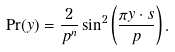<formula> <loc_0><loc_0><loc_500><loc_500>\Pr ( y ) = \frac { 2 } { p ^ { n } } \sin ^ { 2 } \left ( \frac { \pi y \cdot s } { p } \right ) .</formula> 